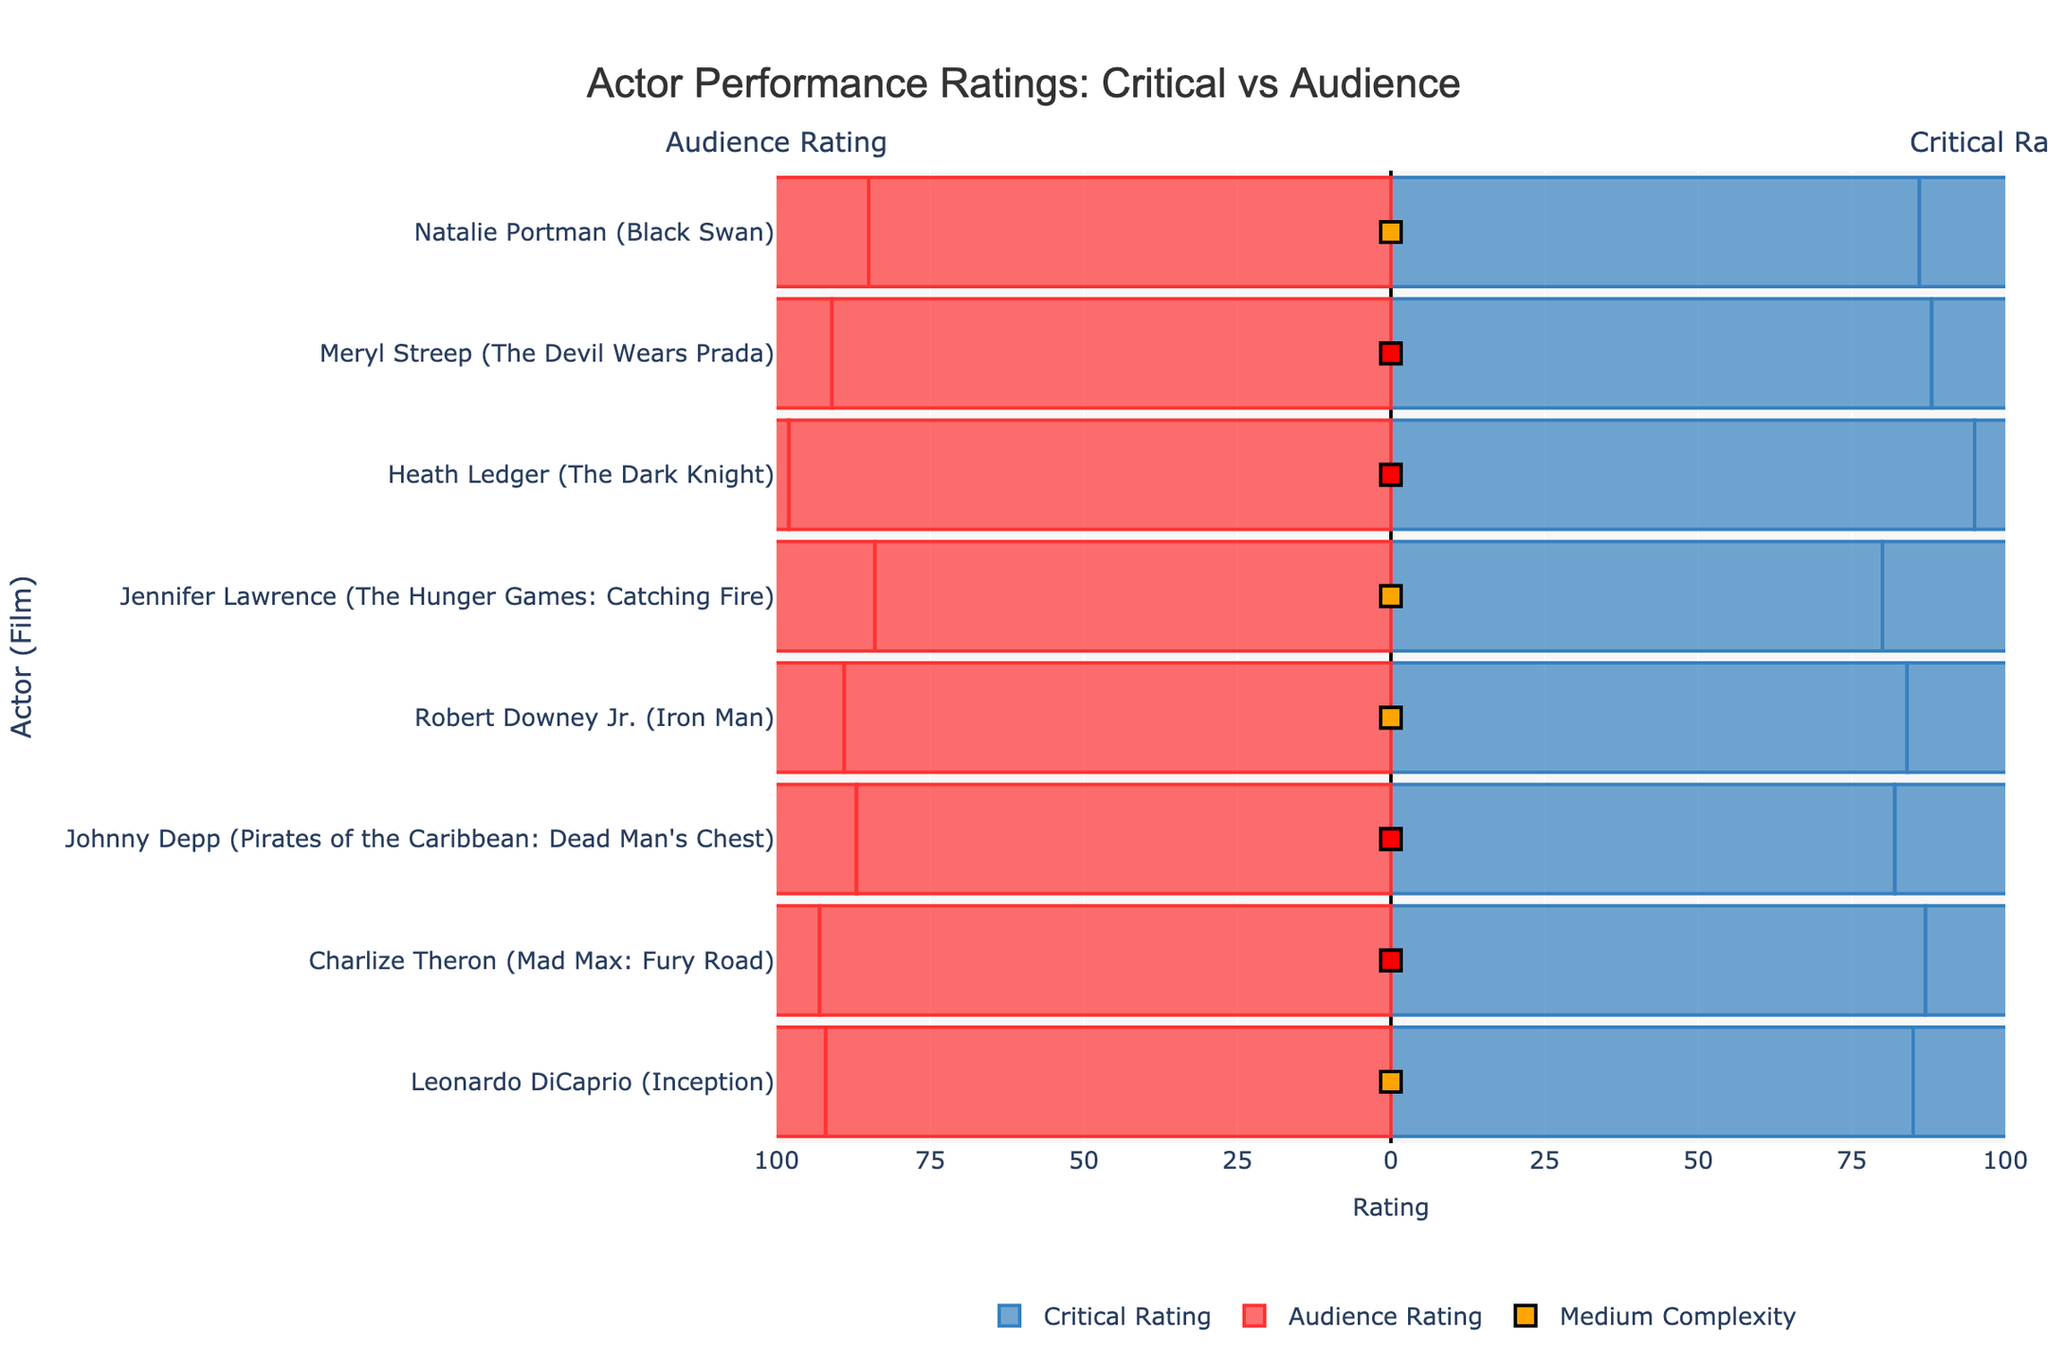What is the difference between critical and audience ratings for Heath Ledger in The Dark Knight? To find the difference, look at the critical and audience ratings for Heath Ledger. The critical rating is 95, and the audience rating is 97. The difference is 97 - 95.
Answer: 2 Who received the highest critical rating, and what was it? Observe the critical ratings for all actors. Heath Ledger received the highest rating, which is 95.
Answer: Heath Ledger, 95 How does the makeup/wardrobe complexity vary among the actors? Note the color-coded markers indicating makeup/wardrobe complexity. Heath Ledger and Meryl Streep have high complexity (red), Leonardo DiCaprio, Natalie Portman, Jennifer Lawrence, and Robert Downey Jr. have medium complexity (orange).
Answer: High: Heath Ledger, Meryl Streep; Medium: Leonardo DiCaprio, Natalie Portman, Jennifer Lawrence, Robert Downey Jr Which actor received the highest audience rating, and what was it? Check the audience ratings for all actors. Heath Ledger received the highest audience rating of 99.
Answer: Heath Ledger, 99 What is the combined difference in critical and audience ratings for Meryl Streep and Charlize Theron? For Meryl Streep: Critical (90) - Audience (88) = 2; For Charlize Theron: Critical (87) - Audience (89) = -2; Combined difference is 2 (up) + 2 (down) = 0
Answer: 0 Among the actors with medium makeup/wardrobe complexity, who received the highest critical rating? Filter actors with medium complexity, and compare their critical ratings. Robert Downey Jr. had the highest critical rating of 84 among the medium complexity category.
Answer: Robert Downey Jr Which actor showed the smallest difference in ratings between critical and audience reviews? Compare the absolute difference between critical and audience ratings for each actor. Natalie Portman (Black Swan) had a difference of 1, which is the smallest.
Answer: Natalie Portman, Black Swan Is there a trend in audience ratings related to the complexity of the wardrobe and makeup? Examine the audience ratings for different complexity levels. High complexity (like Heath Ledger, Meryl Streep) generally has higher audience ratings compared to medium complexity.
Answer: Higher complexity tends to have higher ratings What is the average audience rating for actors with high makeup/wardrobe complexity? Sum audience ratings for actors with high complexity: Heath Ledger (99), Meryl Streep (91), Charlize Theron (90), Johnny Depp (85). The total is 365. Divide by the number of actors (4).
Answer: 365/4 = 91.25 Which actor has the most significant discrepancy between critical and audience ratings? Calculate the absolute difference for each actor. Johnny Depp has the largest difference, with critical rating (82) and audience rating (87), a difference of 5.
Answer: Johnny Depp, difference is 5 